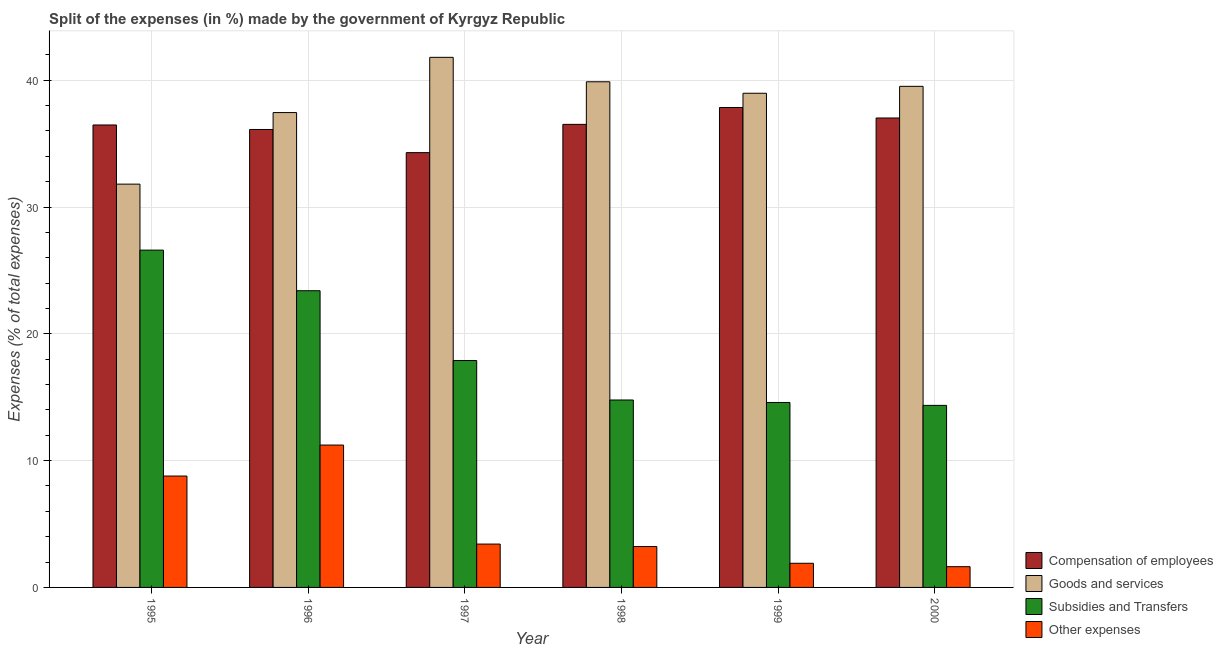How many different coloured bars are there?
Provide a short and direct response. 4. Are the number of bars per tick equal to the number of legend labels?
Make the answer very short. Yes. Are the number of bars on each tick of the X-axis equal?
Offer a terse response. Yes. In how many cases, is the number of bars for a given year not equal to the number of legend labels?
Give a very brief answer. 0. What is the percentage of amount spent on goods and services in 1996?
Offer a very short reply. 37.45. Across all years, what is the maximum percentage of amount spent on other expenses?
Your response must be concise. 11.23. Across all years, what is the minimum percentage of amount spent on goods and services?
Offer a terse response. 31.8. In which year was the percentage of amount spent on compensation of employees minimum?
Give a very brief answer. 1997. What is the total percentage of amount spent on other expenses in the graph?
Offer a very short reply. 30.2. What is the difference between the percentage of amount spent on goods and services in 1996 and that in 1999?
Make the answer very short. -1.52. What is the difference between the percentage of amount spent on subsidies in 1995 and the percentage of amount spent on goods and services in 2000?
Offer a terse response. 12.24. What is the average percentage of amount spent on subsidies per year?
Keep it short and to the point. 18.6. In how many years, is the percentage of amount spent on compensation of employees greater than 14 %?
Your answer should be compact. 6. What is the ratio of the percentage of amount spent on subsidies in 1997 to that in 2000?
Ensure brevity in your answer.  1.25. Is the percentage of amount spent on goods and services in 1997 less than that in 2000?
Offer a very short reply. No. What is the difference between the highest and the second highest percentage of amount spent on subsidies?
Offer a terse response. 3.2. What is the difference between the highest and the lowest percentage of amount spent on subsidies?
Provide a short and direct response. 12.24. Is the sum of the percentage of amount spent on goods and services in 1995 and 2000 greater than the maximum percentage of amount spent on other expenses across all years?
Provide a succinct answer. Yes. Is it the case that in every year, the sum of the percentage of amount spent on compensation of employees and percentage of amount spent on goods and services is greater than the sum of percentage of amount spent on other expenses and percentage of amount spent on subsidies?
Keep it short and to the point. Yes. What does the 1st bar from the left in 1995 represents?
Your answer should be very brief. Compensation of employees. What does the 3rd bar from the right in 1997 represents?
Ensure brevity in your answer.  Goods and services. Is it the case that in every year, the sum of the percentage of amount spent on compensation of employees and percentage of amount spent on goods and services is greater than the percentage of amount spent on subsidies?
Your response must be concise. Yes. How many bars are there?
Provide a short and direct response. 24. How many years are there in the graph?
Your response must be concise. 6. What is the difference between two consecutive major ticks on the Y-axis?
Provide a succinct answer. 10. Are the values on the major ticks of Y-axis written in scientific E-notation?
Provide a short and direct response. No. Does the graph contain any zero values?
Offer a terse response. No. Does the graph contain grids?
Keep it short and to the point. Yes. How are the legend labels stacked?
Keep it short and to the point. Vertical. What is the title of the graph?
Offer a terse response. Split of the expenses (in %) made by the government of Kyrgyz Republic. Does "Social Protection" appear as one of the legend labels in the graph?
Your answer should be compact. No. What is the label or title of the Y-axis?
Offer a terse response. Expenses (% of total expenses). What is the Expenses (% of total expenses) in Compensation of employees in 1995?
Your response must be concise. 36.47. What is the Expenses (% of total expenses) in Goods and services in 1995?
Provide a short and direct response. 31.8. What is the Expenses (% of total expenses) in Subsidies and Transfers in 1995?
Your response must be concise. 26.6. What is the Expenses (% of total expenses) in Other expenses in 1995?
Offer a very short reply. 8.78. What is the Expenses (% of total expenses) of Compensation of employees in 1996?
Your answer should be very brief. 36.11. What is the Expenses (% of total expenses) of Goods and services in 1996?
Give a very brief answer. 37.45. What is the Expenses (% of total expenses) of Subsidies and Transfers in 1996?
Offer a terse response. 23.4. What is the Expenses (% of total expenses) in Other expenses in 1996?
Make the answer very short. 11.23. What is the Expenses (% of total expenses) of Compensation of employees in 1997?
Your response must be concise. 34.29. What is the Expenses (% of total expenses) of Goods and services in 1997?
Provide a short and direct response. 41.8. What is the Expenses (% of total expenses) in Subsidies and Transfers in 1997?
Keep it short and to the point. 17.89. What is the Expenses (% of total expenses) of Other expenses in 1997?
Provide a short and direct response. 3.42. What is the Expenses (% of total expenses) in Compensation of employees in 1998?
Provide a succinct answer. 36.52. What is the Expenses (% of total expenses) of Goods and services in 1998?
Provide a short and direct response. 39.88. What is the Expenses (% of total expenses) of Subsidies and Transfers in 1998?
Give a very brief answer. 14.78. What is the Expenses (% of total expenses) in Other expenses in 1998?
Provide a short and direct response. 3.22. What is the Expenses (% of total expenses) in Compensation of employees in 1999?
Provide a short and direct response. 37.85. What is the Expenses (% of total expenses) of Goods and services in 1999?
Your answer should be compact. 38.97. What is the Expenses (% of total expenses) in Subsidies and Transfers in 1999?
Your answer should be compact. 14.58. What is the Expenses (% of total expenses) in Other expenses in 1999?
Offer a very short reply. 1.9. What is the Expenses (% of total expenses) of Compensation of employees in 2000?
Your answer should be very brief. 37.02. What is the Expenses (% of total expenses) of Goods and services in 2000?
Your response must be concise. 39.52. What is the Expenses (% of total expenses) of Subsidies and Transfers in 2000?
Your answer should be compact. 14.36. What is the Expenses (% of total expenses) in Other expenses in 2000?
Ensure brevity in your answer.  1.64. Across all years, what is the maximum Expenses (% of total expenses) of Compensation of employees?
Ensure brevity in your answer.  37.85. Across all years, what is the maximum Expenses (% of total expenses) of Goods and services?
Ensure brevity in your answer.  41.8. Across all years, what is the maximum Expenses (% of total expenses) in Subsidies and Transfers?
Your response must be concise. 26.6. Across all years, what is the maximum Expenses (% of total expenses) of Other expenses?
Give a very brief answer. 11.23. Across all years, what is the minimum Expenses (% of total expenses) in Compensation of employees?
Offer a very short reply. 34.29. Across all years, what is the minimum Expenses (% of total expenses) of Goods and services?
Offer a very short reply. 31.8. Across all years, what is the minimum Expenses (% of total expenses) in Subsidies and Transfers?
Offer a terse response. 14.36. Across all years, what is the minimum Expenses (% of total expenses) in Other expenses?
Your response must be concise. 1.64. What is the total Expenses (% of total expenses) in Compensation of employees in the graph?
Offer a very short reply. 218.26. What is the total Expenses (% of total expenses) of Goods and services in the graph?
Your response must be concise. 229.42. What is the total Expenses (% of total expenses) of Subsidies and Transfers in the graph?
Give a very brief answer. 111.61. What is the total Expenses (% of total expenses) in Other expenses in the graph?
Make the answer very short. 30.2. What is the difference between the Expenses (% of total expenses) in Compensation of employees in 1995 and that in 1996?
Give a very brief answer. 0.36. What is the difference between the Expenses (% of total expenses) in Goods and services in 1995 and that in 1996?
Give a very brief answer. -5.64. What is the difference between the Expenses (% of total expenses) of Subsidies and Transfers in 1995 and that in 1996?
Your answer should be compact. 3.2. What is the difference between the Expenses (% of total expenses) of Other expenses in 1995 and that in 1996?
Ensure brevity in your answer.  -2.44. What is the difference between the Expenses (% of total expenses) of Compensation of employees in 1995 and that in 1997?
Ensure brevity in your answer.  2.18. What is the difference between the Expenses (% of total expenses) of Goods and services in 1995 and that in 1997?
Your answer should be very brief. -10. What is the difference between the Expenses (% of total expenses) in Subsidies and Transfers in 1995 and that in 1997?
Make the answer very short. 8.71. What is the difference between the Expenses (% of total expenses) of Other expenses in 1995 and that in 1997?
Keep it short and to the point. 5.37. What is the difference between the Expenses (% of total expenses) of Compensation of employees in 1995 and that in 1998?
Your answer should be compact. -0.05. What is the difference between the Expenses (% of total expenses) of Goods and services in 1995 and that in 1998?
Keep it short and to the point. -8.07. What is the difference between the Expenses (% of total expenses) in Subsidies and Transfers in 1995 and that in 1998?
Keep it short and to the point. 11.82. What is the difference between the Expenses (% of total expenses) in Other expenses in 1995 and that in 1998?
Make the answer very short. 5.56. What is the difference between the Expenses (% of total expenses) of Compensation of employees in 1995 and that in 1999?
Provide a succinct answer. -1.38. What is the difference between the Expenses (% of total expenses) in Goods and services in 1995 and that in 1999?
Your response must be concise. -7.17. What is the difference between the Expenses (% of total expenses) in Subsidies and Transfers in 1995 and that in 1999?
Provide a succinct answer. 12.02. What is the difference between the Expenses (% of total expenses) in Other expenses in 1995 and that in 1999?
Offer a very short reply. 6.88. What is the difference between the Expenses (% of total expenses) in Compensation of employees in 1995 and that in 2000?
Your response must be concise. -0.55. What is the difference between the Expenses (% of total expenses) in Goods and services in 1995 and that in 2000?
Your answer should be very brief. -7.71. What is the difference between the Expenses (% of total expenses) in Subsidies and Transfers in 1995 and that in 2000?
Make the answer very short. 12.24. What is the difference between the Expenses (% of total expenses) of Other expenses in 1995 and that in 2000?
Ensure brevity in your answer.  7.15. What is the difference between the Expenses (% of total expenses) of Compensation of employees in 1996 and that in 1997?
Your answer should be very brief. 1.83. What is the difference between the Expenses (% of total expenses) in Goods and services in 1996 and that in 1997?
Your answer should be very brief. -4.36. What is the difference between the Expenses (% of total expenses) in Subsidies and Transfers in 1996 and that in 1997?
Provide a short and direct response. 5.5. What is the difference between the Expenses (% of total expenses) in Other expenses in 1996 and that in 1997?
Offer a very short reply. 7.81. What is the difference between the Expenses (% of total expenses) in Compensation of employees in 1996 and that in 1998?
Provide a short and direct response. -0.4. What is the difference between the Expenses (% of total expenses) of Goods and services in 1996 and that in 1998?
Give a very brief answer. -2.43. What is the difference between the Expenses (% of total expenses) in Subsidies and Transfers in 1996 and that in 1998?
Provide a short and direct response. 8.62. What is the difference between the Expenses (% of total expenses) in Other expenses in 1996 and that in 1998?
Ensure brevity in your answer.  8. What is the difference between the Expenses (% of total expenses) in Compensation of employees in 1996 and that in 1999?
Offer a terse response. -1.73. What is the difference between the Expenses (% of total expenses) of Goods and services in 1996 and that in 1999?
Offer a terse response. -1.52. What is the difference between the Expenses (% of total expenses) of Subsidies and Transfers in 1996 and that in 1999?
Keep it short and to the point. 8.81. What is the difference between the Expenses (% of total expenses) of Other expenses in 1996 and that in 1999?
Provide a short and direct response. 9.32. What is the difference between the Expenses (% of total expenses) of Compensation of employees in 1996 and that in 2000?
Provide a short and direct response. -0.91. What is the difference between the Expenses (% of total expenses) of Goods and services in 1996 and that in 2000?
Keep it short and to the point. -2.07. What is the difference between the Expenses (% of total expenses) of Subsidies and Transfers in 1996 and that in 2000?
Offer a very short reply. 9.04. What is the difference between the Expenses (% of total expenses) of Other expenses in 1996 and that in 2000?
Offer a very short reply. 9.59. What is the difference between the Expenses (% of total expenses) of Compensation of employees in 1997 and that in 1998?
Offer a very short reply. -2.23. What is the difference between the Expenses (% of total expenses) of Goods and services in 1997 and that in 1998?
Provide a succinct answer. 1.93. What is the difference between the Expenses (% of total expenses) in Subsidies and Transfers in 1997 and that in 1998?
Your answer should be very brief. 3.11. What is the difference between the Expenses (% of total expenses) of Other expenses in 1997 and that in 1998?
Offer a very short reply. 0.2. What is the difference between the Expenses (% of total expenses) of Compensation of employees in 1997 and that in 1999?
Offer a very short reply. -3.56. What is the difference between the Expenses (% of total expenses) in Goods and services in 1997 and that in 1999?
Provide a short and direct response. 2.83. What is the difference between the Expenses (% of total expenses) of Subsidies and Transfers in 1997 and that in 1999?
Your answer should be very brief. 3.31. What is the difference between the Expenses (% of total expenses) of Other expenses in 1997 and that in 1999?
Provide a succinct answer. 1.51. What is the difference between the Expenses (% of total expenses) in Compensation of employees in 1997 and that in 2000?
Ensure brevity in your answer.  -2.73. What is the difference between the Expenses (% of total expenses) in Goods and services in 1997 and that in 2000?
Offer a terse response. 2.29. What is the difference between the Expenses (% of total expenses) of Subsidies and Transfers in 1997 and that in 2000?
Your answer should be very brief. 3.54. What is the difference between the Expenses (% of total expenses) in Other expenses in 1997 and that in 2000?
Your answer should be very brief. 1.78. What is the difference between the Expenses (% of total expenses) in Compensation of employees in 1998 and that in 1999?
Your answer should be compact. -1.33. What is the difference between the Expenses (% of total expenses) of Goods and services in 1998 and that in 1999?
Your response must be concise. 0.91. What is the difference between the Expenses (% of total expenses) of Subsidies and Transfers in 1998 and that in 1999?
Offer a terse response. 0.2. What is the difference between the Expenses (% of total expenses) of Other expenses in 1998 and that in 1999?
Offer a very short reply. 1.32. What is the difference between the Expenses (% of total expenses) of Compensation of employees in 1998 and that in 2000?
Ensure brevity in your answer.  -0.5. What is the difference between the Expenses (% of total expenses) in Goods and services in 1998 and that in 2000?
Make the answer very short. 0.36. What is the difference between the Expenses (% of total expenses) of Subsidies and Transfers in 1998 and that in 2000?
Your answer should be very brief. 0.42. What is the difference between the Expenses (% of total expenses) of Other expenses in 1998 and that in 2000?
Offer a very short reply. 1.59. What is the difference between the Expenses (% of total expenses) of Compensation of employees in 1999 and that in 2000?
Offer a very short reply. 0.83. What is the difference between the Expenses (% of total expenses) of Goods and services in 1999 and that in 2000?
Provide a succinct answer. -0.55. What is the difference between the Expenses (% of total expenses) in Subsidies and Transfers in 1999 and that in 2000?
Give a very brief answer. 0.23. What is the difference between the Expenses (% of total expenses) of Other expenses in 1999 and that in 2000?
Your answer should be very brief. 0.27. What is the difference between the Expenses (% of total expenses) in Compensation of employees in 1995 and the Expenses (% of total expenses) in Goods and services in 1996?
Keep it short and to the point. -0.98. What is the difference between the Expenses (% of total expenses) in Compensation of employees in 1995 and the Expenses (% of total expenses) in Subsidies and Transfers in 1996?
Offer a terse response. 13.07. What is the difference between the Expenses (% of total expenses) of Compensation of employees in 1995 and the Expenses (% of total expenses) of Other expenses in 1996?
Give a very brief answer. 25.24. What is the difference between the Expenses (% of total expenses) in Goods and services in 1995 and the Expenses (% of total expenses) in Subsidies and Transfers in 1996?
Give a very brief answer. 8.41. What is the difference between the Expenses (% of total expenses) of Goods and services in 1995 and the Expenses (% of total expenses) of Other expenses in 1996?
Give a very brief answer. 20.58. What is the difference between the Expenses (% of total expenses) of Subsidies and Transfers in 1995 and the Expenses (% of total expenses) of Other expenses in 1996?
Your response must be concise. 15.37. What is the difference between the Expenses (% of total expenses) in Compensation of employees in 1995 and the Expenses (% of total expenses) in Goods and services in 1997?
Ensure brevity in your answer.  -5.33. What is the difference between the Expenses (% of total expenses) in Compensation of employees in 1995 and the Expenses (% of total expenses) in Subsidies and Transfers in 1997?
Ensure brevity in your answer.  18.58. What is the difference between the Expenses (% of total expenses) of Compensation of employees in 1995 and the Expenses (% of total expenses) of Other expenses in 1997?
Your answer should be compact. 33.05. What is the difference between the Expenses (% of total expenses) of Goods and services in 1995 and the Expenses (% of total expenses) of Subsidies and Transfers in 1997?
Your response must be concise. 13.91. What is the difference between the Expenses (% of total expenses) of Goods and services in 1995 and the Expenses (% of total expenses) of Other expenses in 1997?
Make the answer very short. 28.38. What is the difference between the Expenses (% of total expenses) of Subsidies and Transfers in 1995 and the Expenses (% of total expenses) of Other expenses in 1997?
Your answer should be very brief. 23.18. What is the difference between the Expenses (% of total expenses) of Compensation of employees in 1995 and the Expenses (% of total expenses) of Goods and services in 1998?
Your answer should be very brief. -3.41. What is the difference between the Expenses (% of total expenses) in Compensation of employees in 1995 and the Expenses (% of total expenses) in Subsidies and Transfers in 1998?
Provide a short and direct response. 21.69. What is the difference between the Expenses (% of total expenses) in Compensation of employees in 1995 and the Expenses (% of total expenses) in Other expenses in 1998?
Make the answer very short. 33.25. What is the difference between the Expenses (% of total expenses) in Goods and services in 1995 and the Expenses (% of total expenses) in Subsidies and Transfers in 1998?
Give a very brief answer. 17.02. What is the difference between the Expenses (% of total expenses) of Goods and services in 1995 and the Expenses (% of total expenses) of Other expenses in 1998?
Offer a terse response. 28.58. What is the difference between the Expenses (% of total expenses) of Subsidies and Transfers in 1995 and the Expenses (% of total expenses) of Other expenses in 1998?
Provide a short and direct response. 23.38. What is the difference between the Expenses (% of total expenses) of Compensation of employees in 1995 and the Expenses (% of total expenses) of Goods and services in 1999?
Your response must be concise. -2.5. What is the difference between the Expenses (% of total expenses) in Compensation of employees in 1995 and the Expenses (% of total expenses) in Subsidies and Transfers in 1999?
Offer a very short reply. 21.88. What is the difference between the Expenses (% of total expenses) of Compensation of employees in 1995 and the Expenses (% of total expenses) of Other expenses in 1999?
Keep it short and to the point. 34.56. What is the difference between the Expenses (% of total expenses) in Goods and services in 1995 and the Expenses (% of total expenses) in Subsidies and Transfers in 1999?
Keep it short and to the point. 17.22. What is the difference between the Expenses (% of total expenses) of Goods and services in 1995 and the Expenses (% of total expenses) of Other expenses in 1999?
Provide a short and direct response. 29.9. What is the difference between the Expenses (% of total expenses) in Subsidies and Transfers in 1995 and the Expenses (% of total expenses) in Other expenses in 1999?
Offer a terse response. 24.7. What is the difference between the Expenses (% of total expenses) in Compensation of employees in 1995 and the Expenses (% of total expenses) in Goods and services in 2000?
Your answer should be very brief. -3.05. What is the difference between the Expenses (% of total expenses) in Compensation of employees in 1995 and the Expenses (% of total expenses) in Subsidies and Transfers in 2000?
Your answer should be very brief. 22.11. What is the difference between the Expenses (% of total expenses) of Compensation of employees in 1995 and the Expenses (% of total expenses) of Other expenses in 2000?
Provide a succinct answer. 34.83. What is the difference between the Expenses (% of total expenses) of Goods and services in 1995 and the Expenses (% of total expenses) of Subsidies and Transfers in 2000?
Give a very brief answer. 17.45. What is the difference between the Expenses (% of total expenses) in Goods and services in 1995 and the Expenses (% of total expenses) in Other expenses in 2000?
Keep it short and to the point. 30.17. What is the difference between the Expenses (% of total expenses) in Subsidies and Transfers in 1995 and the Expenses (% of total expenses) in Other expenses in 2000?
Offer a terse response. 24.96. What is the difference between the Expenses (% of total expenses) in Compensation of employees in 1996 and the Expenses (% of total expenses) in Goods and services in 1997?
Your answer should be very brief. -5.69. What is the difference between the Expenses (% of total expenses) in Compensation of employees in 1996 and the Expenses (% of total expenses) in Subsidies and Transfers in 1997?
Offer a very short reply. 18.22. What is the difference between the Expenses (% of total expenses) in Compensation of employees in 1996 and the Expenses (% of total expenses) in Other expenses in 1997?
Provide a short and direct response. 32.7. What is the difference between the Expenses (% of total expenses) in Goods and services in 1996 and the Expenses (% of total expenses) in Subsidies and Transfers in 1997?
Offer a terse response. 19.55. What is the difference between the Expenses (% of total expenses) of Goods and services in 1996 and the Expenses (% of total expenses) of Other expenses in 1997?
Provide a short and direct response. 34.03. What is the difference between the Expenses (% of total expenses) in Subsidies and Transfers in 1996 and the Expenses (% of total expenses) in Other expenses in 1997?
Ensure brevity in your answer.  19.98. What is the difference between the Expenses (% of total expenses) in Compensation of employees in 1996 and the Expenses (% of total expenses) in Goods and services in 1998?
Make the answer very short. -3.76. What is the difference between the Expenses (% of total expenses) of Compensation of employees in 1996 and the Expenses (% of total expenses) of Subsidies and Transfers in 1998?
Offer a terse response. 21.33. What is the difference between the Expenses (% of total expenses) of Compensation of employees in 1996 and the Expenses (% of total expenses) of Other expenses in 1998?
Your response must be concise. 32.89. What is the difference between the Expenses (% of total expenses) in Goods and services in 1996 and the Expenses (% of total expenses) in Subsidies and Transfers in 1998?
Your response must be concise. 22.67. What is the difference between the Expenses (% of total expenses) of Goods and services in 1996 and the Expenses (% of total expenses) of Other expenses in 1998?
Provide a succinct answer. 34.22. What is the difference between the Expenses (% of total expenses) in Subsidies and Transfers in 1996 and the Expenses (% of total expenses) in Other expenses in 1998?
Offer a very short reply. 20.17. What is the difference between the Expenses (% of total expenses) in Compensation of employees in 1996 and the Expenses (% of total expenses) in Goods and services in 1999?
Offer a very short reply. -2.86. What is the difference between the Expenses (% of total expenses) of Compensation of employees in 1996 and the Expenses (% of total expenses) of Subsidies and Transfers in 1999?
Offer a very short reply. 21.53. What is the difference between the Expenses (% of total expenses) of Compensation of employees in 1996 and the Expenses (% of total expenses) of Other expenses in 1999?
Your response must be concise. 34.21. What is the difference between the Expenses (% of total expenses) in Goods and services in 1996 and the Expenses (% of total expenses) in Subsidies and Transfers in 1999?
Your answer should be compact. 22.86. What is the difference between the Expenses (% of total expenses) in Goods and services in 1996 and the Expenses (% of total expenses) in Other expenses in 1999?
Give a very brief answer. 35.54. What is the difference between the Expenses (% of total expenses) of Subsidies and Transfers in 1996 and the Expenses (% of total expenses) of Other expenses in 1999?
Your answer should be very brief. 21.49. What is the difference between the Expenses (% of total expenses) in Compensation of employees in 1996 and the Expenses (% of total expenses) in Goods and services in 2000?
Your answer should be very brief. -3.4. What is the difference between the Expenses (% of total expenses) in Compensation of employees in 1996 and the Expenses (% of total expenses) in Subsidies and Transfers in 2000?
Your response must be concise. 21.76. What is the difference between the Expenses (% of total expenses) in Compensation of employees in 1996 and the Expenses (% of total expenses) in Other expenses in 2000?
Make the answer very short. 34.48. What is the difference between the Expenses (% of total expenses) of Goods and services in 1996 and the Expenses (% of total expenses) of Subsidies and Transfers in 2000?
Ensure brevity in your answer.  23.09. What is the difference between the Expenses (% of total expenses) of Goods and services in 1996 and the Expenses (% of total expenses) of Other expenses in 2000?
Make the answer very short. 35.81. What is the difference between the Expenses (% of total expenses) of Subsidies and Transfers in 1996 and the Expenses (% of total expenses) of Other expenses in 2000?
Give a very brief answer. 21.76. What is the difference between the Expenses (% of total expenses) of Compensation of employees in 1997 and the Expenses (% of total expenses) of Goods and services in 1998?
Keep it short and to the point. -5.59. What is the difference between the Expenses (% of total expenses) in Compensation of employees in 1997 and the Expenses (% of total expenses) in Subsidies and Transfers in 1998?
Provide a succinct answer. 19.51. What is the difference between the Expenses (% of total expenses) in Compensation of employees in 1997 and the Expenses (% of total expenses) in Other expenses in 1998?
Offer a terse response. 31.06. What is the difference between the Expenses (% of total expenses) in Goods and services in 1997 and the Expenses (% of total expenses) in Subsidies and Transfers in 1998?
Ensure brevity in your answer.  27.02. What is the difference between the Expenses (% of total expenses) in Goods and services in 1997 and the Expenses (% of total expenses) in Other expenses in 1998?
Provide a succinct answer. 38.58. What is the difference between the Expenses (% of total expenses) in Subsidies and Transfers in 1997 and the Expenses (% of total expenses) in Other expenses in 1998?
Your response must be concise. 14.67. What is the difference between the Expenses (% of total expenses) in Compensation of employees in 1997 and the Expenses (% of total expenses) in Goods and services in 1999?
Your answer should be compact. -4.68. What is the difference between the Expenses (% of total expenses) of Compensation of employees in 1997 and the Expenses (% of total expenses) of Subsidies and Transfers in 1999?
Provide a succinct answer. 19.7. What is the difference between the Expenses (% of total expenses) in Compensation of employees in 1997 and the Expenses (% of total expenses) in Other expenses in 1999?
Make the answer very short. 32.38. What is the difference between the Expenses (% of total expenses) in Goods and services in 1997 and the Expenses (% of total expenses) in Subsidies and Transfers in 1999?
Your answer should be very brief. 27.22. What is the difference between the Expenses (% of total expenses) of Goods and services in 1997 and the Expenses (% of total expenses) of Other expenses in 1999?
Your answer should be compact. 39.9. What is the difference between the Expenses (% of total expenses) of Subsidies and Transfers in 1997 and the Expenses (% of total expenses) of Other expenses in 1999?
Your response must be concise. 15.99. What is the difference between the Expenses (% of total expenses) in Compensation of employees in 1997 and the Expenses (% of total expenses) in Goods and services in 2000?
Make the answer very short. -5.23. What is the difference between the Expenses (% of total expenses) of Compensation of employees in 1997 and the Expenses (% of total expenses) of Subsidies and Transfers in 2000?
Provide a short and direct response. 19.93. What is the difference between the Expenses (% of total expenses) in Compensation of employees in 1997 and the Expenses (% of total expenses) in Other expenses in 2000?
Provide a short and direct response. 32.65. What is the difference between the Expenses (% of total expenses) in Goods and services in 1997 and the Expenses (% of total expenses) in Subsidies and Transfers in 2000?
Provide a succinct answer. 27.45. What is the difference between the Expenses (% of total expenses) in Goods and services in 1997 and the Expenses (% of total expenses) in Other expenses in 2000?
Offer a very short reply. 40.17. What is the difference between the Expenses (% of total expenses) of Subsidies and Transfers in 1997 and the Expenses (% of total expenses) of Other expenses in 2000?
Offer a very short reply. 16.26. What is the difference between the Expenses (% of total expenses) of Compensation of employees in 1998 and the Expenses (% of total expenses) of Goods and services in 1999?
Provide a succinct answer. -2.45. What is the difference between the Expenses (% of total expenses) of Compensation of employees in 1998 and the Expenses (% of total expenses) of Subsidies and Transfers in 1999?
Keep it short and to the point. 21.93. What is the difference between the Expenses (% of total expenses) of Compensation of employees in 1998 and the Expenses (% of total expenses) of Other expenses in 1999?
Your answer should be very brief. 34.61. What is the difference between the Expenses (% of total expenses) in Goods and services in 1998 and the Expenses (% of total expenses) in Subsidies and Transfers in 1999?
Provide a short and direct response. 25.29. What is the difference between the Expenses (% of total expenses) of Goods and services in 1998 and the Expenses (% of total expenses) of Other expenses in 1999?
Offer a terse response. 37.97. What is the difference between the Expenses (% of total expenses) in Subsidies and Transfers in 1998 and the Expenses (% of total expenses) in Other expenses in 1999?
Offer a terse response. 12.88. What is the difference between the Expenses (% of total expenses) of Compensation of employees in 1998 and the Expenses (% of total expenses) of Goods and services in 2000?
Ensure brevity in your answer.  -3. What is the difference between the Expenses (% of total expenses) of Compensation of employees in 1998 and the Expenses (% of total expenses) of Subsidies and Transfers in 2000?
Offer a terse response. 22.16. What is the difference between the Expenses (% of total expenses) of Compensation of employees in 1998 and the Expenses (% of total expenses) of Other expenses in 2000?
Keep it short and to the point. 34.88. What is the difference between the Expenses (% of total expenses) of Goods and services in 1998 and the Expenses (% of total expenses) of Subsidies and Transfers in 2000?
Keep it short and to the point. 25.52. What is the difference between the Expenses (% of total expenses) in Goods and services in 1998 and the Expenses (% of total expenses) in Other expenses in 2000?
Ensure brevity in your answer.  38.24. What is the difference between the Expenses (% of total expenses) of Subsidies and Transfers in 1998 and the Expenses (% of total expenses) of Other expenses in 2000?
Give a very brief answer. 13.14. What is the difference between the Expenses (% of total expenses) of Compensation of employees in 1999 and the Expenses (% of total expenses) of Goods and services in 2000?
Offer a terse response. -1.67. What is the difference between the Expenses (% of total expenses) in Compensation of employees in 1999 and the Expenses (% of total expenses) in Subsidies and Transfers in 2000?
Your answer should be compact. 23.49. What is the difference between the Expenses (% of total expenses) of Compensation of employees in 1999 and the Expenses (% of total expenses) of Other expenses in 2000?
Your response must be concise. 36.21. What is the difference between the Expenses (% of total expenses) of Goods and services in 1999 and the Expenses (% of total expenses) of Subsidies and Transfers in 2000?
Your answer should be very brief. 24.61. What is the difference between the Expenses (% of total expenses) of Goods and services in 1999 and the Expenses (% of total expenses) of Other expenses in 2000?
Ensure brevity in your answer.  37.33. What is the difference between the Expenses (% of total expenses) of Subsidies and Transfers in 1999 and the Expenses (% of total expenses) of Other expenses in 2000?
Your response must be concise. 12.95. What is the average Expenses (% of total expenses) of Compensation of employees per year?
Your answer should be very brief. 36.38. What is the average Expenses (% of total expenses) of Goods and services per year?
Offer a very short reply. 38.24. What is the average Expenses (% of total expenses) of Subsidies and Transfers per year?
Your answer should be very brief. 18.6. What is the average Expenses (% of total expenses) of Other expenses per year?
Give a very brief answer. 5.03. In the year 1995, what is the difference between the Expenses (% of total expenses) in Compensation of employees and Expenses (% of total expenses) in Goods and services?
Give a very brief answer. 4.67. In the year 1995, what is the difference between the Expenses (% of total expenses) of Compensation of employees and Expenses (% of total expenses) of Subsidies and Transfers?
Offer a very short reply. 9.87. In the year 1995, what is the difference between the Expenses (% of total expenses) of Compensation of employees and Expenses (% of total expenses) of Other expenses?
Provide a succinct answer. 27.69. In the year 1995, what is the difference between the Expenses (% of total expenses) in Goods and services and Expenses (% of total expenses) in Subsidies and Transfers?
Give a very brief answer. 5.2. In the year 1995, what is the difference between the Expenses (% of total expenses) in Goods and services and Expenses (% of total expenses) in Other expenses?
Offer a terse response. 23.02. In the year 1995, what is the difference between the Expenses (% of total expenses) in Subsidies and Transfers and Expenses (% of total expenses) in Other expenses?
Offer a very short reply. 17.82. In the year 1996, what is the difference between the Expenses (% of total expenses) of Compensation of employees and Expenses (% of total expenses) of Goods and services?
Offer a terse response. -1.33. In the year 1996, what is the difference between the Expenses (% of total expenses) in Compensation of employees and Expenses (% of total expenses) in Subsidies and Transfers?
Your answer should be compact. 12.72. In the year 1996, what is the difference between the Expenses (% of total expenses) of Compensation of employees and Expenses (% of total expenses) of Other expenses?
Give a very brief answer. 24.89. In the year 1996, what is the difference between the Expenses (% of total expenses) in Goods and services and Expenses (% of total expenses) in Subsidies and Transfers?
Your answer should be very brief. 14.05. In the year 1996, what is the difference between the Expenses (% of total expenses) in Goods and services and Expenses (% of total expenses) in Other expenses?
Offer a very short reply. 26.22. In the year 1996, what is the difference between the Expenses (% of total expenses) of Subsidies and Transfers and Expenses (% of total expenses) of Other expenses?
Provide a short and direct response. 12.17. In the year 1997, what is the difference between the Expenses (% of total expenses) of Compensation of employees and Expenses (% of total expenses) of Goods and services?
Your answer should be compact. -7.52. In the year 1997, what is the difference between the Expenses (% of total expenses) of Compensation of employees and Expenses (% of total expenses) of Subsidies and Transfers?
Offer a very short reply. 16.39. In the year 1997, what is the difference between the Expenses (% of total expenses) in Compensation of employees and Expenses (% of total expenses) in Other expenses?
Give a very brief answer. 30.87. In the year 1997, what is the difference between the Expenses (% of total expenses) in Goods and services and Expenses (% of total expenses) in Subsidies and Transfers?
Offer a terse response. 23.91. In the year 1997, what is the difference between the Expenses (% of total expenses) of Goods and services and Expenses (% of total expenses) of Other expenses?
Your response must be concise. 38.38. In the year 1997, what is the difference between the Expenses (% of total expenses) of Subsidies and Transfers and Expenses (% of total expenses) of Other expenses?
Offer a very short reply. 14.47. In the year 1998, what is the difference between the Expenses (% of total expenses) in Compensation of employees and Expenses (% of total expenses) in Goods and services?
Provide a succinct answer. -3.36. In the year 1998, what is the difference between the Expenses (% of total expenses) of Compensation of employees and Expenses (% of total expenses) of Subsidies and Transfers?
Your answer should be compact. 21.74. In the year 1998, what is the difference between the Expenses (% of total expenses) of Compensation of employees and Expenses (% of total expenses) of Other expenses?
Ensure brevity in your answer.  33.29. In the year 1998, what is the difference between the Expenses (% of total expenses) in Goods and services and Expenses (% of total expenses) in Subsidies and Transfers?
Your response must be concise. 25.1. In the year 1998, what is the difference between the Expenses (% of total expenses) of Goods and services and Expenses (% of total expenses) of Other expenses?
Offer a terse response. 36.65. In the year 1998, what is the difference between the Expenses (% of total expenses) in Subsidies and Transfers and Expenses (% of total expenses) in Other expenses?
Your response must be concise. 11.56. In the year 1999, what is the difference between the Expenses (% of total expenses) of Compensation of employees and Expenses (% of total expenses) of Goods and services?
Your response must be concise. -1.12. In the year 1999, what is the difference between the Expenses (% of total expenses) of Compensation of employees and Expenses (% of total expenses) of Subsidies and Transfers?
Your response must be concise. 23.26. In the year 1999, what is the difference between the Expenses (% of total expenses) in Compensation of employees and Expenses (% of total expenses) in Other expenses?
Give a very brief answer. 35.94. In the year 1999, what is the difference between the Expenses (% of total expenses) in Goods and services and Expenses (% of total expenses) in Subsidies and Transfers?
Your answer should be compact. 24.39. In the year 1999, what is the difference between the Expenses (% of total expenses) of Goods and services and Expenses (% of total expenses) of Other expenses?
Give a very brief answer. 37.07. In the year 1999, what is the difference between the Expenses (% of total expenses) in Subsidies and Transfers and Expenses (% of total expenses) in Other expenses?
Provide a succinct answer. 12.68. In the year 2000, what is the difference between the Expenses (% of total expenses) of Compensation of employees and Expenses (% of total expenses) of Goods and services?
Your answer should be very brief. -2.5. In the year 2000, what is the difference between the Expenses (% of total expenses) of Compensation of employees and Expenses (% of total expenses) of Subsidies and Transfers?
Keep it short and to the point. 22.66. In the year 2000, what is the difference between the Expenses (% of total expenses) in Compensation of employees and Expenses (% of total expenses) in Other expenses?
Make the answer very short. 35.38. In the year 2000, what is the difference between the Expenses (% of total expenses) in Goods and services and Expenses (% of total expenses) in Subsidies and Transfers?
Provide a succinct answer. 25.16. In the year 2000, what is the difference between the Expenses (% of total expenses) in Goods and services and Expenses (% of total expenses) in Other expenses?
Your answer should be very brief. 37.88. In the year 2000, what is the difference between the Expenses (% of total expenses) of Subsidies and Transfers and Expenses (% of total expenses) of Other expenses?
Provide a short and direct response. 12.72. What is the ratio of the Expenses (% of total expenses) in Compensation of employees in 1995 to that in 1996?
Keep it short and to the point. 1.01. What is the ratio of the Expenses (% of total expenses) of Goods and services in 1995 to that in 1996?
Offer a terse response. 0.85. What is the ratio of the Expenses (% of total expenses) of Subsidies and Transfers in 1995 to that in 1996?
Your response must be concise. 1.14. What is the ratio of the Expenses (% of total expenses) in Other expenses in 1995 to that in 1996?
Your response must be concise. 0.78. What is the ratio of the Expenses (% of total expenses) of Compensation of employees in 1995 to that in 1997?
Your answer should be compact. 1.06. What is the ratio of the Expenses (% of total expenses) of Goods and services in 1995 to that in 1997?
Offer a terse response. 0.76. What is the ratio of the Expenses (% of total expenses) in Subsidies and Transfers in 1995 to that in 1997?
Offer a terse response. 1.49. What is the ratio of the Expenses (% of total expenses) in Other expenses in 1995 to that in 1997?
Make the answer very short. 2.57. What is the ratio of the Expenses (% of total expenses) in Goods and services in 1995 to that in 1998?
Provide a succinct answer. 0.8. What is the ratio of the Expenses (% of total expenses) of Subsidies and Transfers in 1995 to that in 1998?
Your answer should be compact. 1.8. What is the ratio of the Expenses (% of total expenses) in Other expenses in 1995 to that in 1998?
Make the answer very short. 2.72. What is the ratio of the Expenses (% of total expenses) in Compensation of employees in 1995 to that in 1999?
Make the answer very short. 0.96. What is the ratio of the Expenses (% of total expenses) in Goods and services in 1995 to that in 1999?
Keep it short and to the point. 0.82. What is the ratio of the Expenses (% of total expenses) in Subsidies and Transfers in 1995 to that in 1999?
Provide a short and direct response. 1.82. What is the ratio of the Expenses (% of total expenses) of Other expenses in 1995 to that in 1999?
Keep it short and to the point. 4.61. What is the ratio of the Expenses (% of total expenses) of Compensation of employees in 1995 to that in 2000?
Provide a short and direct response. 0.99. What is the ratio of the Expenses (% of total expenses) in Goods and services in 1995 to that in 2000?
Provide a succinct answer. 0.8. What is the ratio of the Expenses (% of total expenses) of Subsidies and Transfers in 1995 to that in 2000?
Provide a short and direct response. 1.85. What is the ratio of the Expenses (% of total expenses) in Other expenses in 1995 to that in 2000?
Offer a very short reply. 5.37. What is the ratio of the Expenses (% of total expenses) in Compensation of employees in 1996 to that in 1997?
Give a very brief answer. 1.05. What is the ratio of the Expenses (% of total expenses) in Goods and services in 1996 to that in 1997?
Provide a succinct answer. 0.9. What is the ratio of the Expenses (% of total expenses) in Subsidies and Transfers in 1996 to that in 1997?
Offer a terse response. 1.31. What is the ratio of the Expenses (% of total expenses) in Other expenses in 1996 to that in 1997?
Make the answer very short. 3.28. What is the ratio of the Expenses (% of total expenses) of Goods and services in 1996 to that in 1998?
Offer a terse response. 0.94. What is the ratio of the Expenses (% of total expenses) of Subsidies and Transfers in 1996 to that in 1998?
Your response must be concise. 1.58. What is the ratio of the Expenses (% of total expenses) of Other expenses in 1996 to that in 1998?
Provide a succinct answer. 3.48. What is the ratio of the Expenses (% of total expenses) of Compensation of employees in 1996 to that in 1999?
Ensure brevity in your answer.  0.95. What is the ratio of the Expenses (% of total expenses) of Goods and services in 1996 to that in 1999?
Provide a short and direct response. 0.96. What is the ratio of the Expenses (% of total expenses) of Subsidies and Transfers in 1996 to that in 1999?
Provide a succinct answer. 1.6. What is the ratio of the Expenses (% of total expenses) in Other expenses in 1996 to that in 1999?
Your answer should be very brief. 5.89. What is the ratio of the Expenses (% of total expenses) of Compensation of employees in 1996 to that in 2000?
Ensure brevity in your answer.  0.98. What is the ratio of the Expenses (% of total expenses) in Goods and services in 1996 to that in 2000?
Your answer should be very brief. 0.95. What is the ratio of the Expenses (% of total expenses) of Subsidies and Transfers in 1996 to that in 2000?
Provide a succinct answer. 1.63. What is the ratio of the Expenses (% of total expenses) of Other expenses in 1996 to that in 2000?
Your answer should be compact. 6.86. What is the ratio of the Expenses (% of total expenses) in Compensation of employees in 1997 to that in 1998?
Make the answer very short. 0.94. What is the ratio of the Expenses (% of total expenses) of Goods and services in 1997 to that in 1998?
Make the answer very short. 1.05. What is the ratio of the Expenses (% of total expenses) in Subsidies and Transfers in 1997 to that in 1998?
Provide a succinct answer. 1.21. What is the ratio of the Expenses (% of total expenses) in Other expenses in 1997 to that in 1998?
Your response must be concise. 1.06. What is the ratio of the Expenses (% of total expenses) of Compensation of employees in 1997 to that in 1999?
Give a very brief answer. 0.91. What is the ratio of the Expenses (% of total expenses) of Goods and services in 1997 to that in 1999?
Give a very brief answer. 1.07. What is the ratio of the Expenses (% of total expenses) of Subsidies and Transfers in 1997 to that in 1999?
Your answer should be very brief. 1.23. What is the ratio of the Expenses (% of total expenses) of Other expenses in 1997 to that in 1999?
Your answer should be very brief. 1.8. What is the ratio of the Expenses (% of total expenses) of Compensation of employees in 1997 to that in 2000?
Give a very brief answer. 0.93. What is the ratio of the Expenses (% of total expenses) in Goods and services in 1997 to that in 2000?
Offer a terse response. 1.06. What is the ratio of the Expenses (% of total expenses) of Subsidies and Transfers in 1997 to that in 2000?
Provide a short and direct response. 1.25. What is the ratio of the Expenses (% of total expenses) of Other expenses in 1997 to that in 2000?
Ensure brevity in your answer.  2.09. What is the ratio of the Expenses (% of total expenses) in Compensation of employees in 1998 to that in 1999?
Provide a succinct answer. 0.96. What is the ratio of the Expenses (% of total expenses) in Goods and services in 1998 to that in 1999?
Make the answer very short. 1.02. What is the ratio of the Expenses (% of total expenses) in Subsidies and Transfers in 1998 to that in 1999?
Offer a terse response. 1.01. What is the ratio of the Expenses (% of total expenses) in Other expenses in 1998 to that in 1999?
Your response must be concise. 1.69. What is the ratio of the Expenses (% of total expenses) of Compensation of employees in 1998 to that in 2000?
Ensure brevity in your answer.  0.99. What is the ratio of the Expenses (% of total expenses) in Goods and services in 1998 to that in 2000?
Ensure brevity in your answer.  1.01. What is the ratio of the Expenses (% of total expenses) of Subsidies and Transfers in 1998 to that in 2000?
Offer a terse response. 1.03. What is the ratio of the Expenses (% of total expenses) in Other expenses in 1998 to that in 2000?
Your answer should be very brief. 1.97. What is the ratio of the Expenses (% of total expenses) in Compensation of employees in 1999 to that in 2000?
Offer a very short reply. 1.02. What is the ratio of the Expenses (% of total expenses) in Goods and services in 1999 to that in 2000?
Offer a very short reply. 0.99. What is the ratio of the Expenses (% of total expenses) of Subsidies and Transfers in 1999 to that in 2000?
Give a very brief answer. 1.02. What is the ratio of the Expenses (% of total expenses) of Other expenses in 1999 to that in 2000?
Ensure brevity in your answer.  1.16. What is the difference between the highest and the second highest Expenses (% of total expenses) of Compensation of employees?
Ensure brevity in your answer.  0.83. What is the difference between the highest and the second highest Expenses (% of total expenses) of Goods and services?
Offer a very short reply. 1.93. What is the difference between the highest and the second highest Expenses (% of total expenses) of Subsidies and Transfers?
Ensure brevity in your answer.  3.2. What is the difference between the highest and the second highest Expenses (% of total expenses) in Other expenses?
Give a very brief answer. 2.44. What is the difference between the highest and the lowest Expenses (% of total expenses) in Compensation of employees?
Make the answer very short. 3.56. What is the difference between the highest and the lowest Expenses (% of total expenses) in Goods and services?
Your answer should be very brief. 10. What is the difference between the highest and the lowest Expenses (% of total expenses) in Subsidies and Transfers?
Your answer should be compact. 12.24. What is the difference between the highest and the lowest Expenses (% of total expenses) of Other expenses?
Provide a succinct answer. 9.59. 